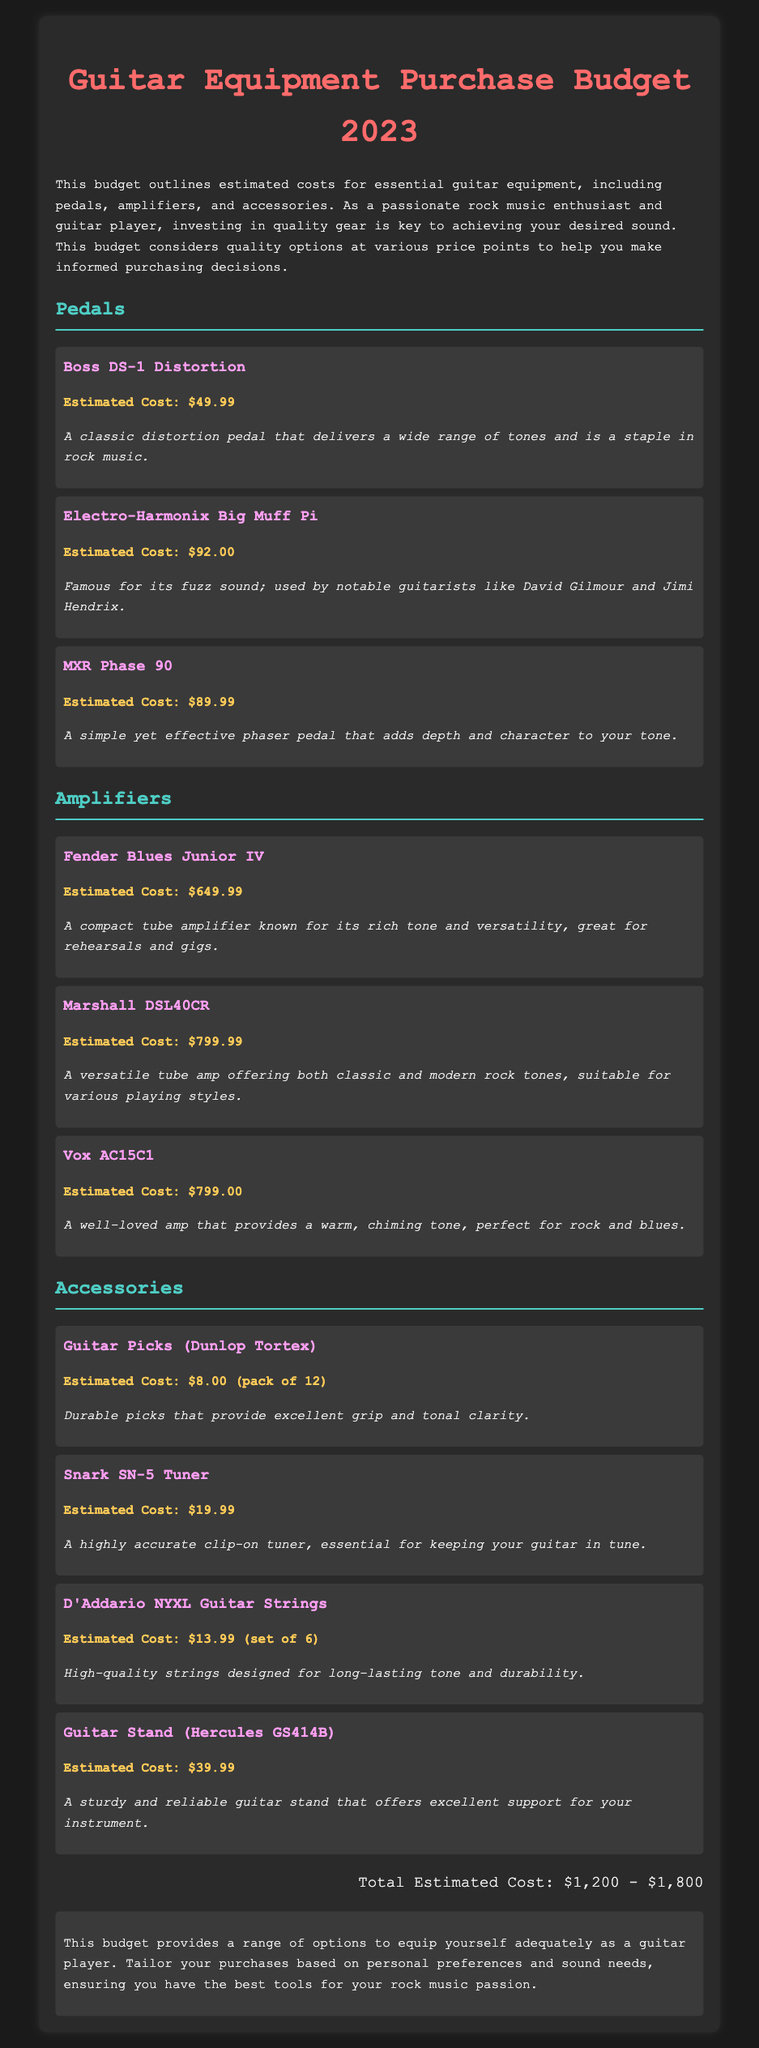what is the estimated cost of the Boss DS-1 Distortion? The estimated cost for the Boss DS-1 Distortion pedal is mentioned in the document.
Answer: $49.99 how many guitar picks are included in a pack of Dunlop Tortex? The document specifies that a pack of Dunlop Tortex includes 12 guitar picks.
Answer: pack of 12 what is the total estimated cost range for the equipment? The document provides a total estimated cost range based on all items listed.
Answer: $1,200 - $1,800 which amplifier is known for its rich tone and versatility? The document describes the Fender Blues Junior IV as a compact tube amplifier known for its rich tone and versatility.
Answer: Fender Blues Junior IV which pedal is famous for its fuzz sound? According to the document, the Electro-Harmonix Big Muff Pi is famous for its fuzz sound.
Answer: Electro-Harmonix Big Muff Pi how much does the Snark SN-5 Tuner cost? The document lists the cost of the Snark SN-5 Tuner as stated clearly.
Answer: $19.99 what type of document is this? The document outlines estimated costs for guitar equipment purchases in a structured format.
Answer: budget which item is essential for keeping a guitar in tune? The document highlights that a tuner is essential for keeping a guitar in tune, specifying the Snark SN-5 Tuner.
Answer: Snark SN-5 Tuner which amplifier offers both classic and modern rock tones? The document identifies the Marshall DSL40CR as an amplifier that offers both classic and modern rock tones.
Answer: Marshall DSL40CR 